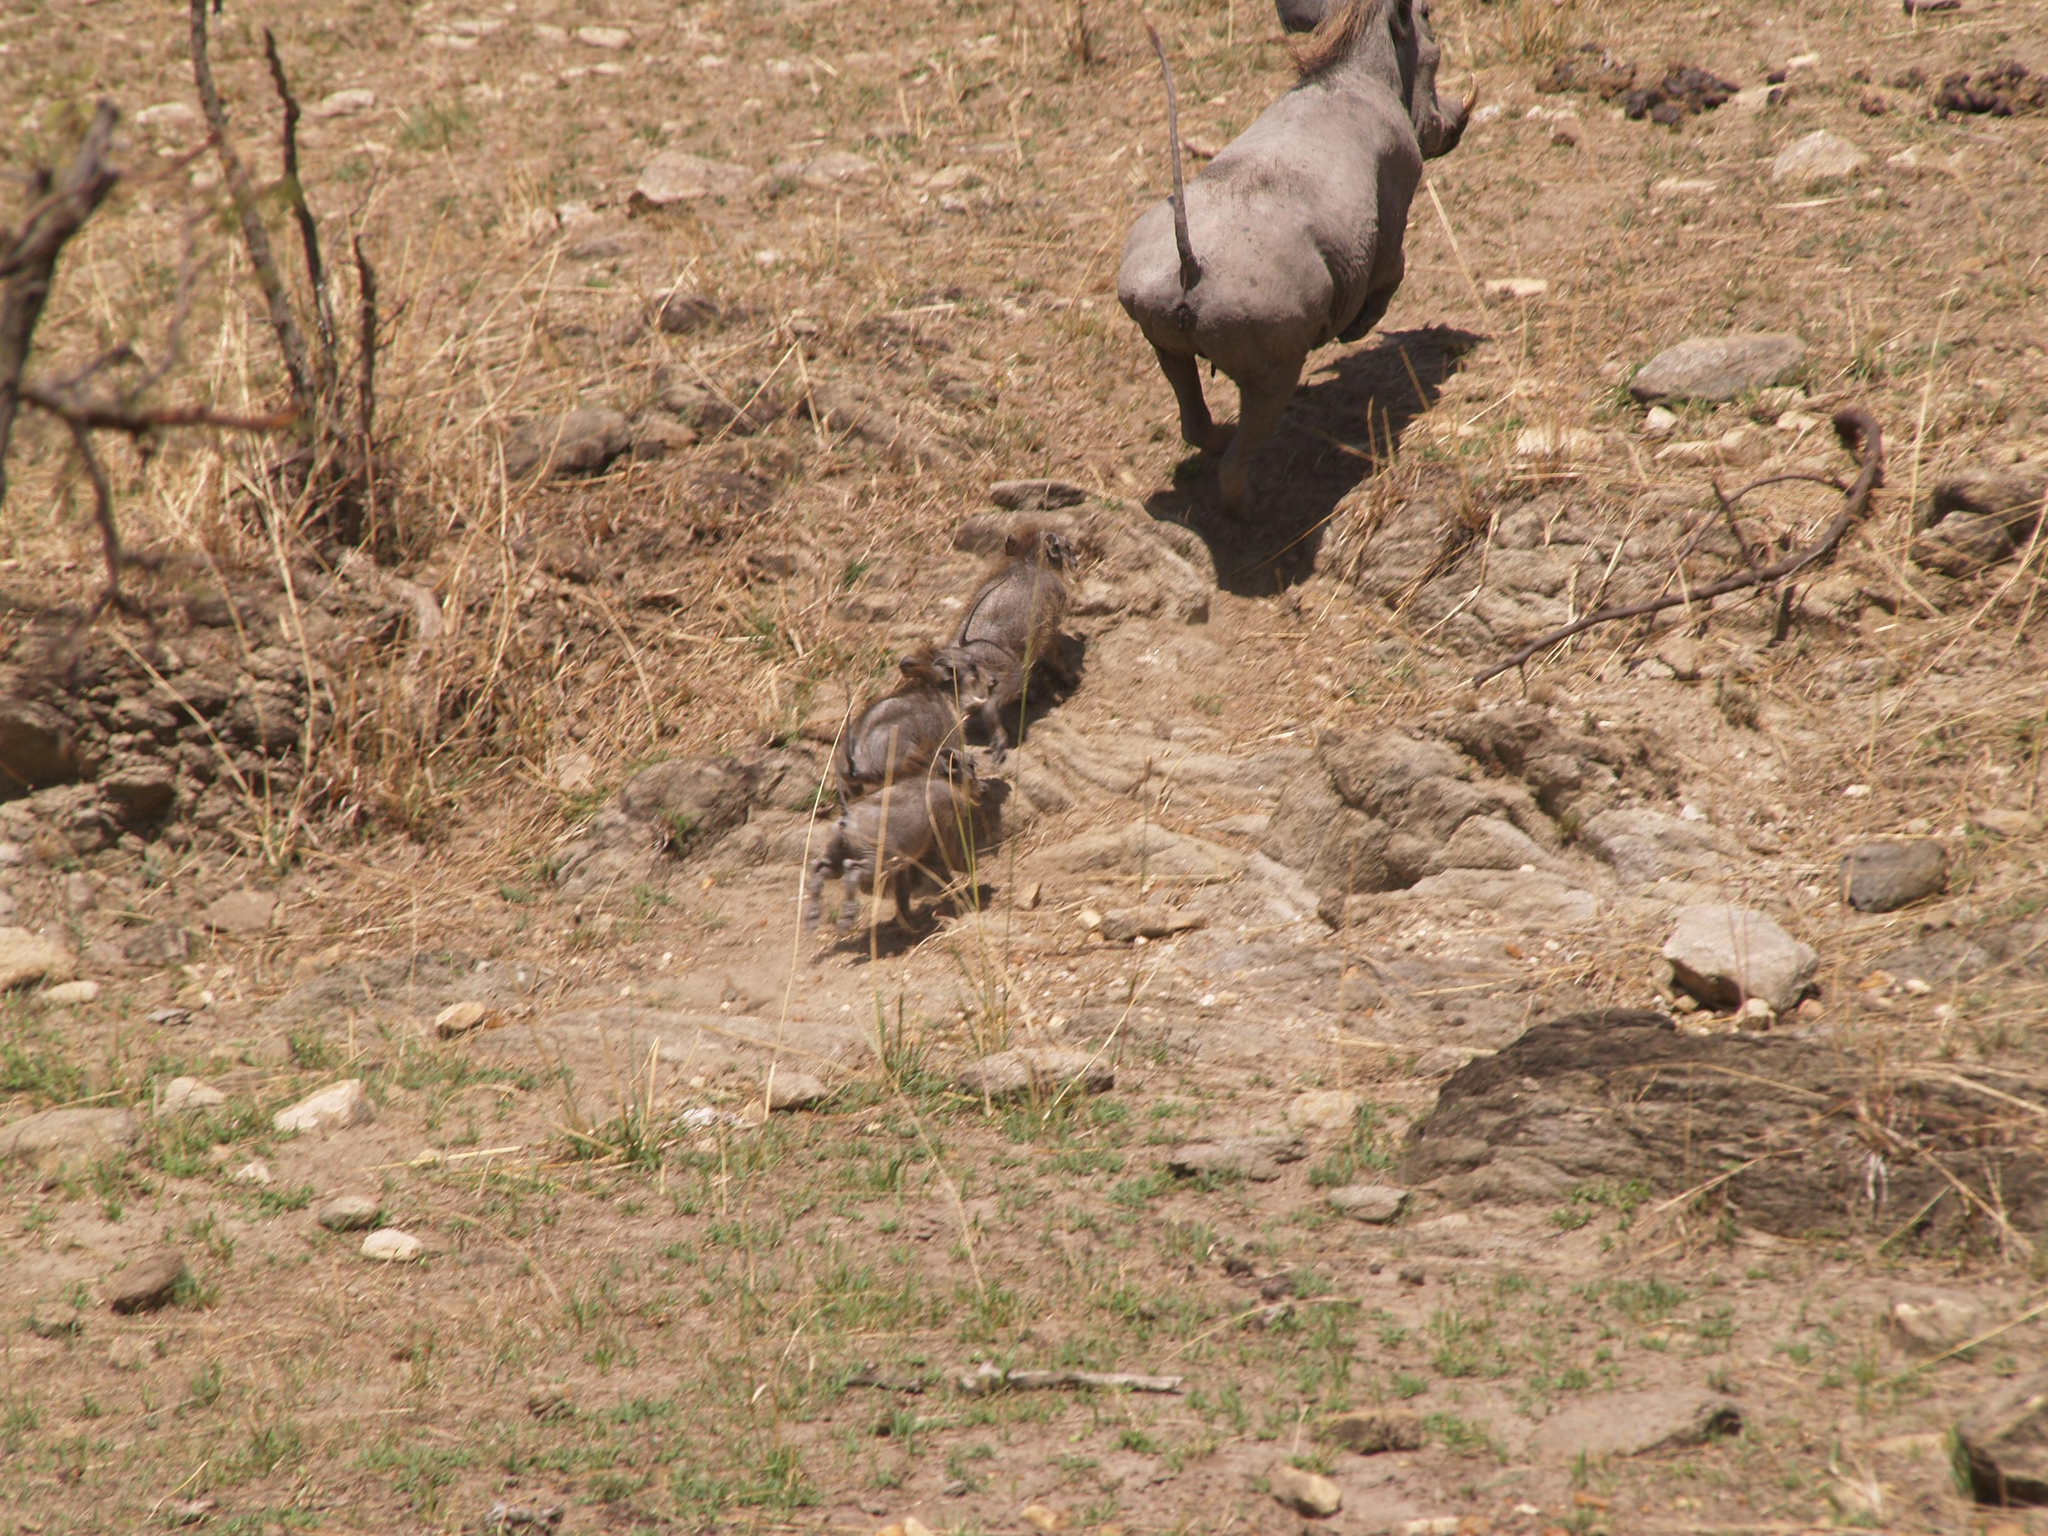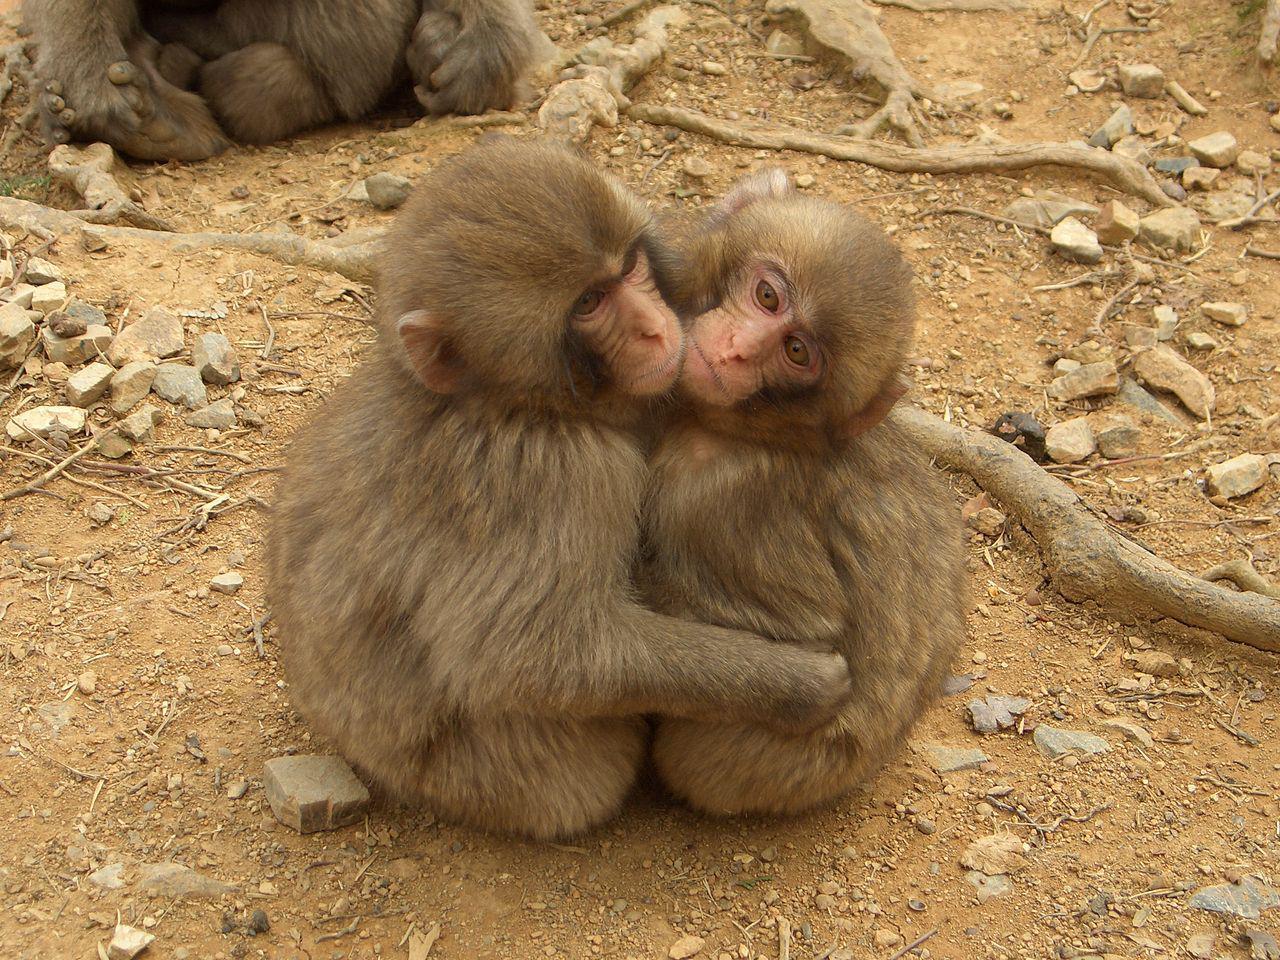The first image is the image on the left, the second image is the image on the right. For the images displayed, is the sentence "At least one photo contains a monkey on top of a warthog." factually correct? Answer yes or no. No. The first image is the image on the left, the second image is the image on the right. Evaluate the accuracy of this statement regarding the images: "The right image has a monkey interacting with a warthog.". Is it true? Answer yes or no. No. 